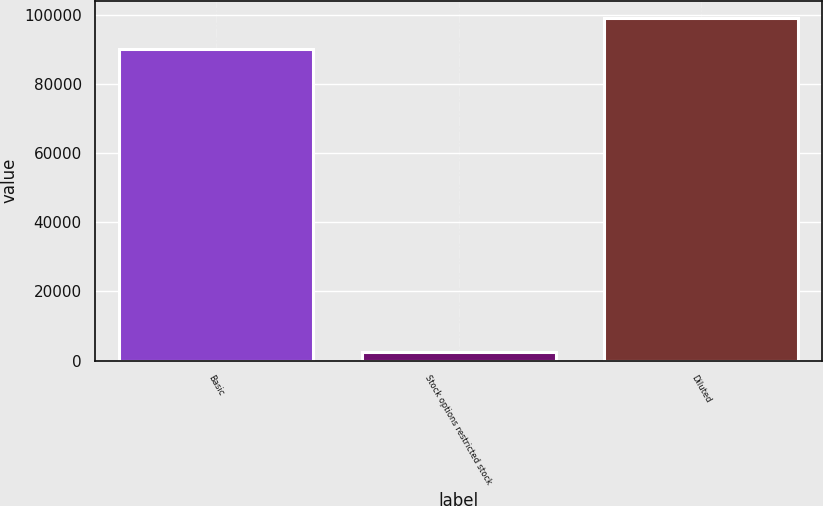Convert chart to OTSL. <chart><loc_0><loc_0><loc_500><loc_500><bar_chart><fcel>Basic<fcel>Stock options restricted stock<fcel>Diluted<nl><fcel>90120<fcel>2500<fcel>99132<nl></chart> 